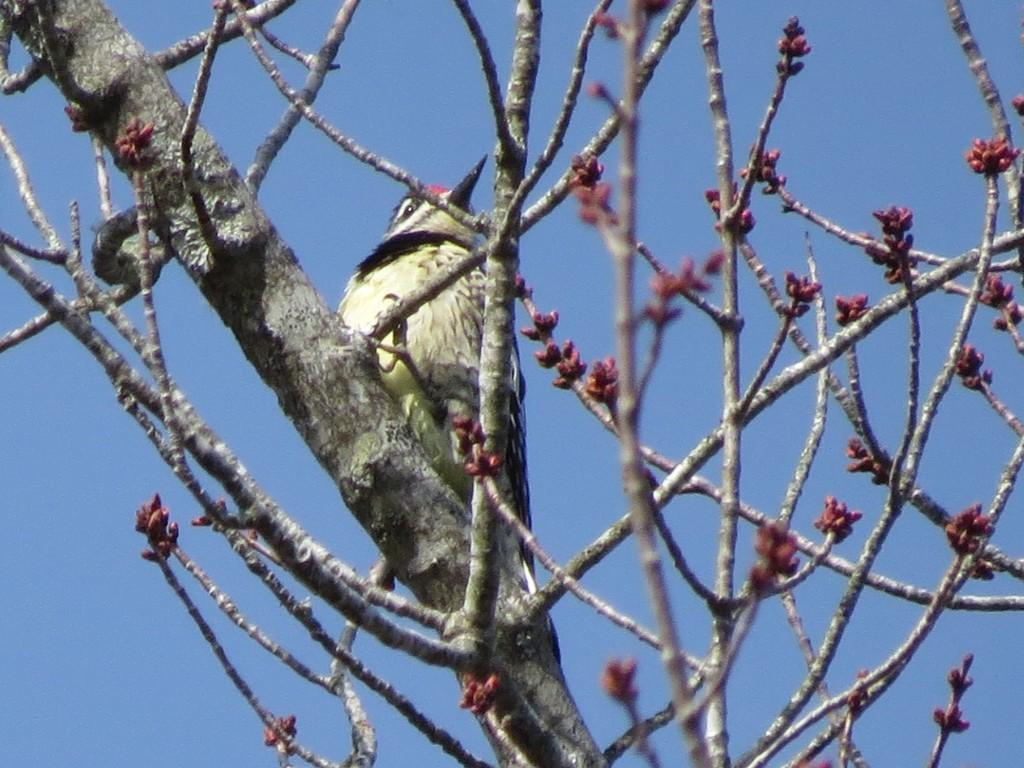What type of animal can be seen in the image? There is a bird in the image. Where is the bird located? The bird is on a tree. What can be seen in the background of the image? There is sky visible in the background of the image. What type of regret can be seen on the bird's face in the image? There is no indication of regret on the bird's face in the image, as birds do not experience emotions like regret. 